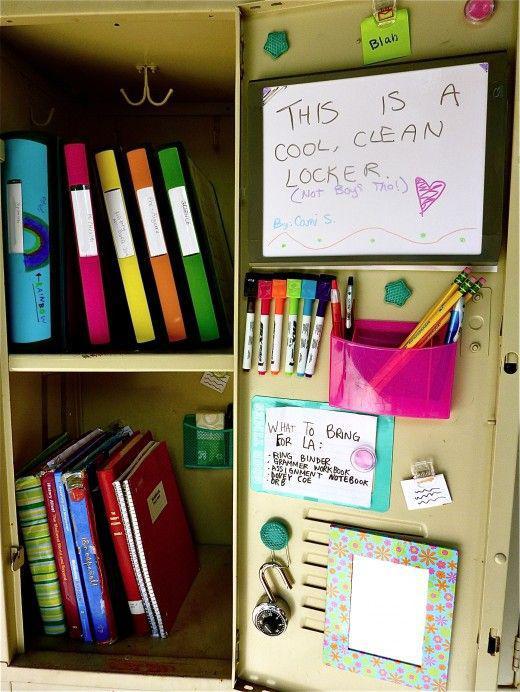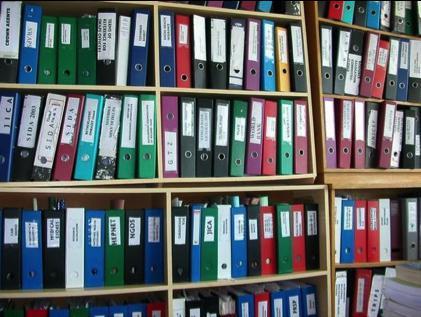The first image is the image on the left, the second image is the image on the right. Given the left and right images, does the statement "Collector cards arranged in plastic pockets of notebook pages are shown in one image." hold true? Answer yes or no. No. 